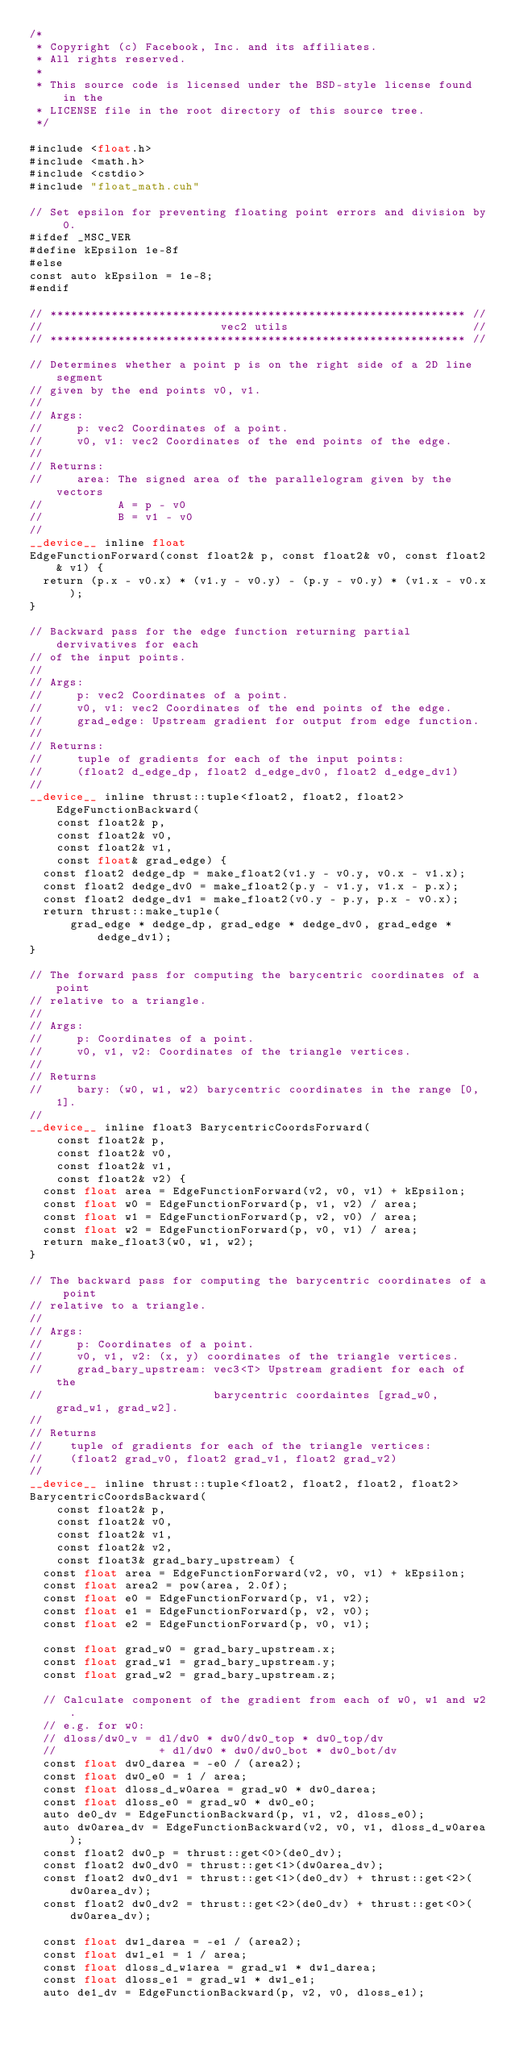Convert code to text. <code><loc_0><loc_0><loc_500><loc_500><_Cuda_>/*
 * Copyright (c) Facebook, Inc. and its affiliates.
 * All rights reserved.
 *
 * This source code is licensed under the BSD-style license found in the
 * LICENSE file in the root directory of this source tree.
 */

#include <float.h>
#include <math.h>
#include <cstdio>
#include "float_math.cuh"

// Set epsilon for preventing floating point errors and division by 0.
#ifdef _MSC_VER
#define kEpsilon 1e-8f
#else
const auto kEpsilon = 1e-8;
#endif

// ************************************************************* //
//                          vec2 utils                           //
// ************************************************************* //

// Determines whether a point p is on the right side of a 2D line segment
// given by the end points v0, v1.
//
// Args:
//     p: vec2 Coordinates of a point.
//     v0, v1: vec2 Coordinates of the end points of the edge.
//
// Returns:
//     area: The signed area of the parallelogram given by the vectors
//           A = p - v0
//           B = v1 - v0
//
__device__ inline float
EdgeFunctionForward(const float2& p, const float2& v0, const float2& v1) {
  return (p.x - v0.x) * (v1.y - v0.y) - (p.y - v0.y) * (v1.x - v0.x);
}

// Backward pass for the edge function returning partial dervivatives for each
// of the input points.
//
// Args:
//     p: vec2 Coordinates of a point.
//     v0, v1: vec2 Coordinates of the end points of the edge.
//     grad_edge: Upstream gradient for output from edge function.
//
// Returns:
//     tuple of gradients for each of the input points:
//     (float2 d_edge_dp, float2 d_edge_dv0, float2 d_edge_dv1)
//
__device__ inline thrust::tuple<float2, float2, float2> EdgeFunctionBackward(
    const float2& p,
    const float2& v0,
    const float2& v1,
    const float& grad_edge) {
  const float2 dedge_dp = make_float2(v1.y - v0.y, v0.x - v1.x);
  const float2 dedge_dv0 = make_float2(p.y - v1.y, v1.x - p.x);
  const float2 dedge_dv1 = make_float2(v0.y - p.y, p.x - v0.x);
  return thrust::make_tuple(
      grad_edge * dedge_dp, grad_edge * dedge_dv0, grad_edge * dedge_dv1);
}

// The forward pass for computing the barycentric coordinates of a point
// relative to a triangle.
//
// Args:
//     p: Coordinates of a point.
//     v0, v1, v2: Coordinates of the triangle vertices.
//
// Returns
//     bary: (w0, w1, w2) barycentric coordinates in the range [0, 1].
//
__device__ inline float3 BarycentricCoordsForward(
    const float2& p,
    const float2& v0,
    const float2& v1,
    const float2& v2) {
  const float area = EdgeFunctionForward(v2, v0, v1) + kEpsilon;
  const float w0 = EdgeFunctionForward(p, v1, v2) / area;
  const float w1 = EdgeFunctionForward(p, v2, v0) / area;
  const float w2 = EdgeFunctionForward(p, v0, v1) / area;
  return make_float3(w0, w1, w2);
}

// The backward pass for computing the barycentric coordinates of a point
// relative to a triangle.
//
// Args:
//     p: Coordinates of a point.
//     v0, v1, v2: (x, y) coordinates of the triangle vertices.
//     grad_bary_upstream: vec3<T> Upstream gradient for each of the
//                         barycentric coordaintes [grad_w0, grad_w1, grad_w2].
//
// Returns
//    tuple of gradients for each of the triangle vertices:
//    (float2 grad_v0, float2 grad_v1, float2 grad_v2)
//
__device__ inline thrust::tuple<float2, float2, float2, float2>
BarycentricCoordsBackward(
    const float2& p,
    const float2& v0,
    const float2& v1,
    const float2& v2,
    const float3& grad_bary_upstream) {
  const float area = EdgeFunctionForward(v2, v0, v1) + kEpsilon;
  const float area2 = pow(area, 2.0f);
  const float e0 = EdgeFunctionForward(p, v1, v2);
  const float e1 = EdgeFunctionForward(p, v2, v0);
  const float e2 = EdgeFunctionForward(p, v0, v1);

  const float grad_w0 = grad_bary_upstream.x;
  const float grad_w1 = grad_bary_upstream.y;
  const float grad_w2 = grad_bary_upstream.z;

  // Calculate component of the gradient from each of w0, w1 and w2.
  // e.g. for w0:
  // dloss/dw0_v = dl/dw0 * dw0/dw0_top * dw0_top/dv
  //               + dl/dw0 * dw0/dw0_bot * dw0_bot/dv
  const float dw0_darea = -e0 / (area2);
  const float dw0_e0 = 1 / area;
  const float dloss_d_w0area = grad_w0 * dw0_darea;
  const float dloss_e0 = grad_w0 * dw0_e0;
  auto de0_dv = EdgeFunctionBackward(p, v1, v2, dloss_e0);
  auto dw0area_dv = EdgeFunctionBackward(v2, v0, v1, dloss_d_w0area);
  const float2 dw0_p = thrust::get<0>(de0_dv);
  const float2 dw0_dv0 = thrust::get<1>(dw0area_dv);
  const float2 dw0_dv1 = thrust::get<1>(de0_dv) + thrust::get<2>(dw0area_dv);
  const float2 dw0_dv2 = thrust::get<2>(de0_dv) + thrust::get<0>(dw0area_dv);

  const float dw1_darea = -e1 / (area2);
  const float dw1_e1 = 1 / area;
  const float dloss_d_w1area = grad_w1 * dw1_darea;
  const float dloss_e1 = grad_w1 * dw1_e1;
  auto de1_dv = EdgeFunctionBackward(p, v2, v0, dloss_e1);</code> 